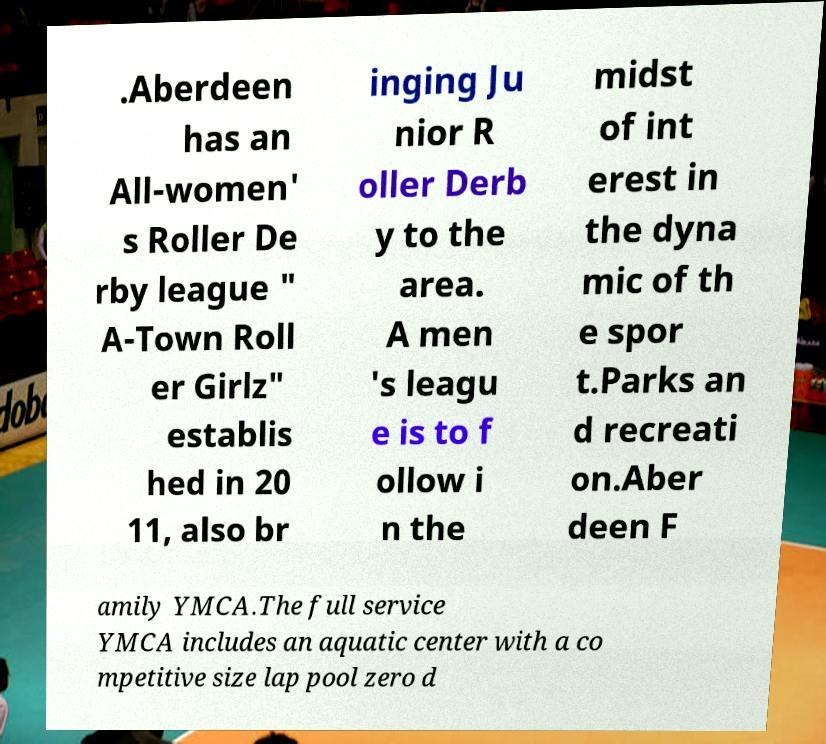There's text embedded in this image that I need extracted. Can you transcribe it verbatim? .Aberdeen has an All-women' s Roller De rby league " A-Town Roll er Girlz" establis hed in 20 11, also br inging Ju nior R oller Derb y to the area. A men 's leagu e is to f ollow i n the midst of int erest in the dyna mic of th e spor t.Parks an d recreati on.Aber deen F amily YMCA.The full service YMCA includes an aquatic center with a co mpetitive size lap pool zero d 